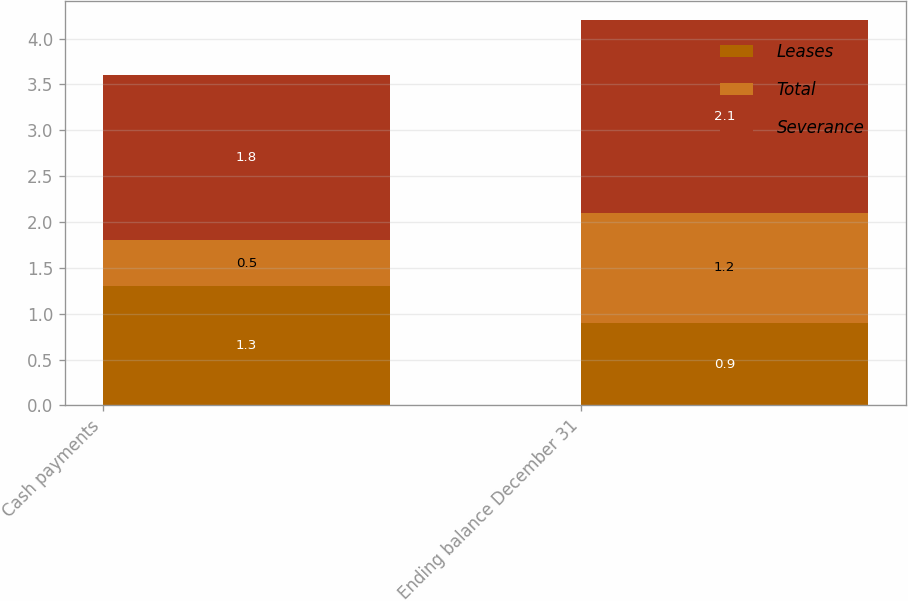<chart> <loc_0><loc_0><loc_500><loc_500><stacked_bar_chart><ecel><fcel>Cash payments<fcel>Ending balance December 31<nl><fcel>Leases<fcel>1.3<fcel>0.9<nl><fcel>Total<fcel>0.5<fcel>1.2<nl><fcel>Severance<fcel>1.8<fcel>2.1<nl></chart> 